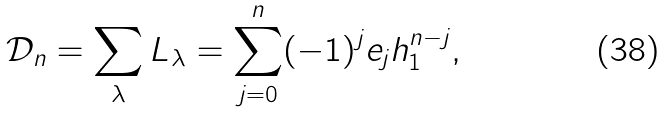<formula> <loc_0><loc_0><loc_500><loc_500>\mathcal { D } _ { n } & = \sum _ { \lambda } L _ { \lambda } = \sum _ { j = 0 } ^ { n } ( - 1 ) ^ { j } e _ { j } h _ { 1 } ^ { n - j } ,</formula> 